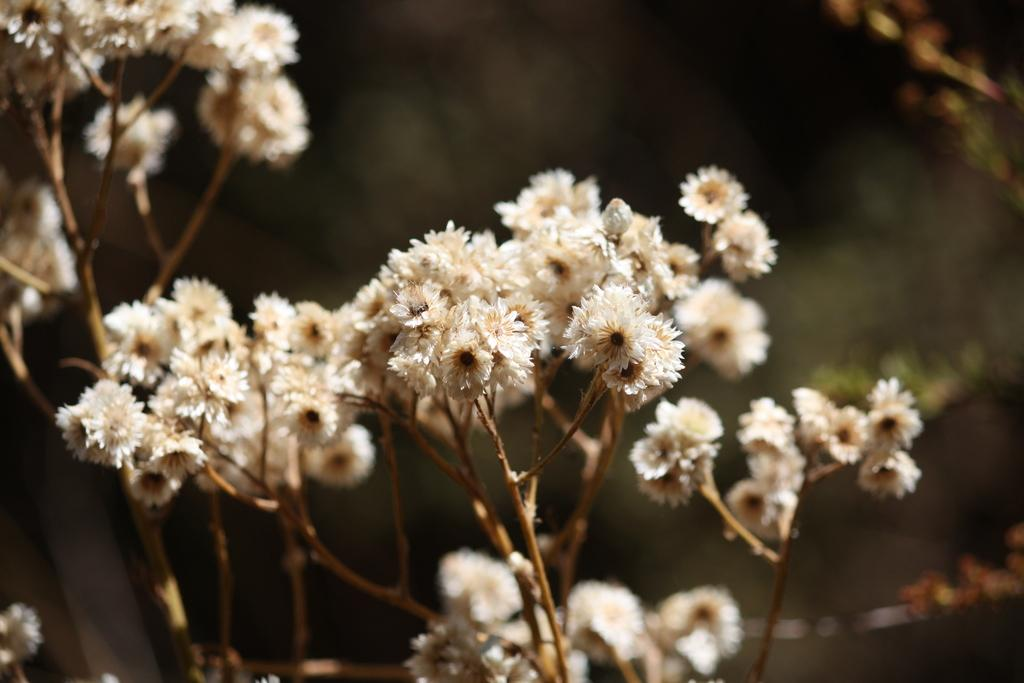What type of living organisms can be seen in the image? There are flowers in the image. What color are the flowers? The flowers are white in color. Can you describe the background of the image? The background of the image is in black and green colors. What type of cushion is being used to care for the flowers in the image? There is no cushion or care for the flowers mentioned in the image; it only shows white flowers against a black and green background. 